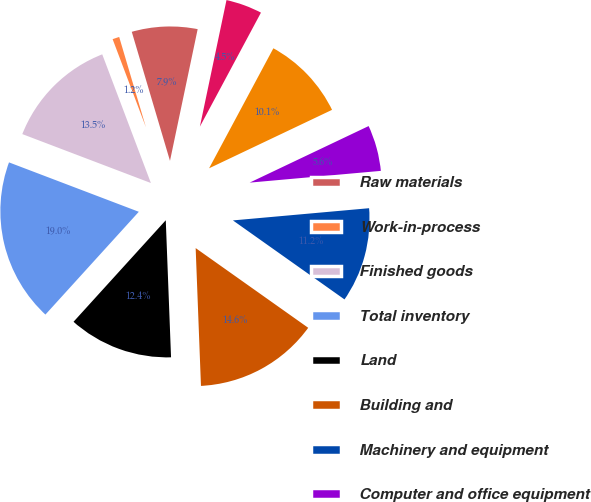Convert chart to OTSL. <chart><loc_0><loc_0><loc_500><loc_500><pie_chart><fcel>Raw materials<fcel>Work-in-process<fcel>Finished goods<fcel>Total inventory<fcel>Land<fcel>Building and<fcel>Machinery and equipment<fcel>Computer and office equipment<fcel>Capitalized software<fcel>Construction-in-process<nl><fcel>7.88%<fcel>1.17%<fcel>13.46%<fcel>19.05%<fcel>12.35%<fcel>14.58%<fcel>11.23%<fcel>5.64%<fcel>10.11%<fcel>4.53%<nl></chart> 